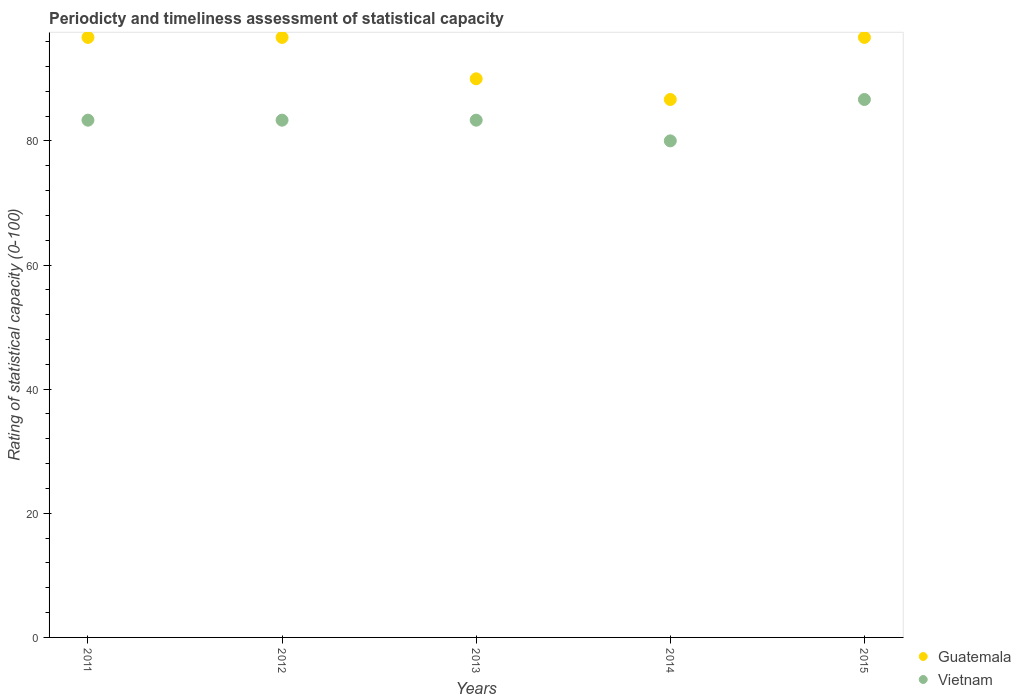How many different coloured dotlines are there?
Offer a very short reply. 2. What is the rating of statistical capacity in Vietnam in 2012?
Provide a succinct answer. 83.33. Across all years, what is the maximum rating of statistical capacity in Guatemala?
Keep it short and to the point. 96.67. Across all years, what is the minimum rating of statistical capacity in Vietnam?
Offer a terse response. 80. In which year was the rating of statistical capacity in Guatemala maximum?
Offer a very short reply. 2015. In which year was the rating of statistical capacity in Vietnam minimum?
Give a very brief answer. 2014. What is the total rating of statistical capacity in Vietnam in the graph?
Offer a terse response. 416.67. What is the difference between the rating of statistical capacity in Vietnam in 2013 and that in 2015?
Your answer should be compact. -3.33. What is the difference between the rating of statistical capacity in Guatemala in 2015 and the rating of statistical capacity in Vietnam in 2013?
Ensure brevity in your answer.  13.33. What is the average rating of statistical capacity in Guatemala per year?
Give a very brief answer. 93.33. In the year 2012, what is the difference between the rating of statistical capacity in Vietnam and rating of statistical capacity in Guatemala?
Offer a very short reply. -13.33. In how many years, is the rating of statistical capacity in Vietnam greater than 16?
Give a very brief answer. 5. What is the ratio of the rating of statistical capacity in Vietnam in 2011 to that in 2014?
Make the answer very short. 1.04. Is the rating of statistical capacity in Vietnam in 2011 less than that in 2014?
Make the answer very short. No. What is the difference between the highest and the second highest rating of statistical capacity in Vietnam?
Offer a terse response. 3.33. What is the difference between the highest and the lowest rating of statistical capacity in Vietnam?
Provide a succinct answer. 6.67. In how many years, is the rating of statistical capacity in Guatemala greater than the average rating of statistical capacity in Guatemala taken over all years?
Offer a very short reply. 3. Is the rating of statistical capacity in Guatemala strictly less than the rating of statistical capacity in Vietnam over the years?
Provide a succinct answer. No. How many years are there in the graph?
Give a very brief answer. 5. Are the values on the major ticks of Y-axis written in scientific E-notation?
Your response must be concise. No. Does the graph contain grids?
Offer a very short reply. No. What is the title of the graph?
Your answer should be compact. Periodicty and timeliness assessment of statistical capacity. What is the label or title of the X-axis?
Offer a terse response. Years. What is the label or title of the Y-axis?
Provide a succinct answer. Rating of statistical capacity (0-100). What is the Rating of statistical capacity (0-100) of Guatemala in 2011?
Offer a very short reply. 96.67. What is the Rating of statistical capacity (0-100) in Vietnam in 2011?
Give a very brief answer. 83.33. What is the Rating of statistical capacity (0-100) in Guatemala in 2012?
Provide a succinct answer. 96.67. What is the Rating of statistical capacity (0-100) of Vietnam in 2012?
Provide a succinct answer. 83.33. What is the Rating of statistical capacity (0-100) of Vietnam in 2013?
Provide a short and direct response. 83.33. What is the Rating of statistical capacity (0-100) in Guatemala in 2014?
Your answer should be very brief. 86.67. What is the Rating of statistical capacity (0-100) of Guatemala in 2015?
Make the answer very short. 96.67. What is the Rating of statistical capacity (0-100) in Vietnam in 2015?
Your answer should be compact. 86.67. Across all years, what is the maximum Rating of statistical capacity (0-100) in Guatemala?
Make the answer very short. 96.67. Across all years, what is the maximum Rating of statistical capacity (0-100) in Vietnam?
Provide a short and direct response. 86.67. Across all years, what is the minimum Rating of statistical capacity (0-100) in Guatemala?
Offer a terse response. 86.67. Across all years, what is the minimum Rating of statistical capacity (0-100) of Vietnam?
Make the answer very short. 80. What is the total Rating of statistical capacity (0-100) in Guatemala in the graph?
Your answer should be compact. 466.67. What is the total Rating of statistical capacity (0-100) in Vietnam in the graph?
Provide a succinct answer. 416.67. What is the difference between the Rating of statistical capacity (0-100) in Guatemala in 2011 and that in 2012?
Your answer should be compact. 0. What is the difference between the Rating of statistical capacity (0-100) of Vietnam in 2011 and that in 2013?
Offer a very short reply. -0. What is the difference between the Rating of statistical capacity (0-100) in Guatemala in 2011 and that in 2015?
Offer a terse response. -0. What is the difference between the Rating of statistical capacity (0-100) in Vietnam in 2011 and that in 2015?
Offer a terse response. -3.33. What is the difference between the Rating of statistical capacity (0-100) in Vietnam in 2012 and that in 2013?
Provide a succinct answer. -0. What is the difference between the Rating of statistical capacity (0-100) in Vietnam in 2012 and that in 2014?
Offer a very short reply. 3.33. What is the difference between the Rating of statistical capacity (0-100) in Guatemala in 2012 and that in 2015?
Give a very brief answer. -0. What is the difference between the Rating of statistical capacity (0-100) of Vietnam in 2012 and that in 2015?
Provide a succinct answer. -3.33. What is the difference between the Rating of statistical capacity (0-100) in Guatemala in 2013 and that in 2014?
Keep it short and to the point. 3.33. What is the difference between the Rating of statistical capacity (0-100) of Guatemala in 2013 and that in 2015?
Your answer should be very brief. -6.67. What is the difference between the Rating of statistical capacity (0-100) in Vietnam in 2013 and that in 2015?
Your answer should be compact. -3.33. What is the difference between the Rating of statistical capacity (0-100) in Vietnam in 2014 and that in 2015?
Your answer should be compact. -6.67. What is the difference between the Rating of statistical capacity (0-100) in Guatemala in 2011 and the Rating of statistical capacity (0-100) in Vietnam in 2012?
Give a very brief answer. 13.33. What is the difference between the Rating of statistical capacity (0-100) of Guatemala in 2011 and the Rating of statistical capacity (0-100) of Vietnam in 2013?
Ensure brevity in your answer.  13.33. What is the difference between the Rating of statistical capacity (0-100) of Guatemala in 2011 and the Rating of statistical capacity (0-100) of Vietnam in 2014?
Offer a terse response. 16.67. What is the difference between the Rating of statistical capacity (0-100) of Guatemala in 2012 and the Rating of statistical capacity (0-100) of Vietnam in 2013?
Provide a short and direct response. 13.33. What is the difference between the Rating of statistical capacity (0-100) of Guatemala in 2012 and the Rating of statistical capacity (0-100) of Vietnam in 2014?
Your response must be concise. 16.67. What is the difference between the Rating of statistical capacity (0-100) in Guatemala in 2013 and the Rating of statistical capacity (0-100) in Vietnam in 2015?
Your answer should be compact. 3.33. What is the average Rating of statistical capacity (0-100) of Guatemala per year?
Offer a very short reply. 93.33. What is the average Rating of statistical capacity (0-100) of Vietnam per year?
Provide a succinct answer. 83.33. In the year 2011, what is the difference between the Rating of statistical capacity (0-100) in Guatemala and Rating of statistical capacity (0-100) in Vietnam?
Offer a terse response. 13.33. In the year 2012, what is the difference between the Rating of statistical capacity (0-100) of Guatemala and Rating of statistical capacity (0-100) of Vietnam?
Give a very brief answer. 13.33. In the year 2014, what is the difference between the Rating of statistical capacity (0-100) of Guatemala and Rating of statistical capacity (0-100) of Vietnam?
Offer a terse response. 6.67. What is the ratio of the Rating of statistical capacity (0-100) of Guatemala in 2011 to that in 2012?
Provide a short and direct response. 1. What is the ratio of the Rating of statistical capacity (0-100) in Vietnam in 2011 to that in 2012?
Make the answer very short. 1. What is the ratio of the Rating of statistical capacity (0-100) in Guatemala in 2011 to that in 2013?
Keep it short and to the point. 1.07. What is the ratio of the Rating of statistical capacity (0-100) of Vietnam in 2011 to that in 2013?
Offer a terse response. 1. What is the ratio of the Rating of statistical capacity (0-100) in Guatemala in 2011 to that in 2014?
Your response must be concise. 1.12. What is the ratio of the Rating of statistical capacity (0-100) in Vietnam in 2011 to that in 2014?
Your response must be concise. 1.04. What is the ratio of the Rating of statistical capacity (0-100) in Guatemala in 2011 to that in 2015?
Give a very brief answer. 1. What is the ratio of the Rating of statistical capacity (0-100) in Vietnam in 2011 to that in 2015?
Ensure brevity in your answer.  0.96. What is the ratio of the Rating of statistical capacity (0-100) in Guatemala in 2012 to that in 2013?
Give a very brief answer. 1.07. What is the ratio of the Rating of statistical capacity (0-100) in Guatemala in 2012 to that in 2014?
Offer a terse response. 1.12. What is the ratio of the Rating of statistical capacity (0-100) in Vietnam in 2012 to that in 2014?
Make the answer very short. 1.04. What is the ratio of the Rating of statistical capacity (0-100) of Guatemala in 2012 to that in 2015?
Ensure brevity in your answer.  1. What is the ratio of the Rating of statistical capacity (0-100) of Vietnam in 2012 to that in 2015?
Give a very brief answer. 0.96. What is the ratio of the Rating of statistical capacity (0-100) of Vietnam in 2013 to that in 2014?
Offer a very short reply. 1.04. What is the ratio of the Rating of statistical capacity (0-100) in Vietnam in 2013 to that in 2015?
Your answer should be compact. 0.96. What is the ratio of the Rating of statistical capacity (0-100) in Guatemala in 2014 to that in 2015?
Offer a terse response. 0.9. What is the difference between the highest and the second highest Rating of statistical capacity (0-100) of Guatemala?
Provide a succinct answer. 0. What is the difference between the highest and the second highest Rating of statistical capacity (0-100) in Vietnam?
Your response must be concise. 3.33. What is the difference between the highest and the lowest Rating of statistical capacity (0-100) in Guatemala?
Offer a terse response. 10. 